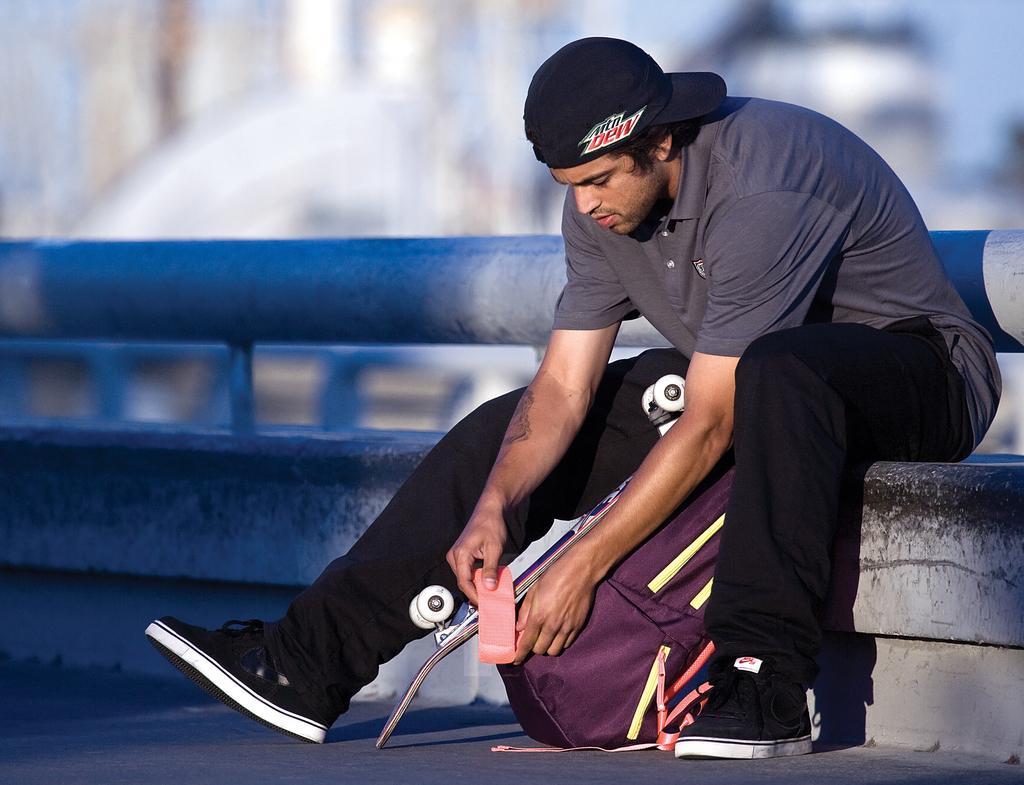Can you describe this image briefly? In this image we can see a person wearing dress and cap is sitting on the floor. In the background, we can see a metal pole, skateboard and a bag placed on the ground. 